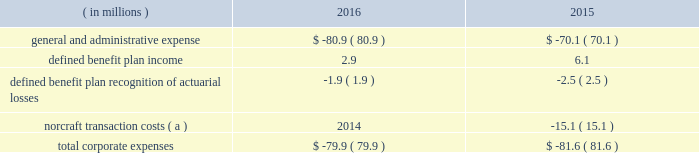Corporate corporate expenses in 2016 benefited from the absence of transaction costs associated with the norcraft acquisition ( $ 15.1 million in 2015 ) .
This benefit was offset by higher employee-related costs and lower defined benefit plan income .
( in millions ) 2016 2015 .
( a ) represents external costs directly related to the acquisition of norcraft and primarily includes expenditures for banking , legal , accounting and other similar services .
In future periods the company may record , in the corporate segment , material expense or income associated with actuarial gains and losses arising from periodic remeasurement of our liabilities for defined benefit plans .
At a minimum the company will remeasure its defined benefit plan liabilities in the fourth quarter of each year .
Remeasurements due to plan amendments and settlements may also occur in interim periods during the year .
Remeasurement of these liabilities attributable to updating our liability discount rates and expected return on assets may , in particular , result in material income or expense recognition .
Liquidity and capital resources our primary liquidity needs are to support working capital requirements , fund capital expenditures and service indebtedness , as well as to finance acquisitions , repurchase shares of our common stock and pay dividends to stockholders , as deemed appropriate .
Our principal sources of liquidity are cash on hand , cash flows from operating activities , availability under our credit facility and debt issuances in the capital markets .
Our operating income is generated by our subsidiaries .
There are no restrictions on the ability of our subsidiaries to pay dividends or make other distributions to fortune brands .
In december 2017 , our board of directors increased the quarterly cash dividend by 11% ( 11 % ) to $ 0.20 per share of our common stock .
Our board of directors will continue to evaluate dividend payment opportunities on a quarterly basis .
There can be no assurance as to when and if future dividends will be paid , and at what level , because the payment of dividends is dependent on our financial condition , results of operations , cash flows , capital requirements and other factors deemed relevant by our board of directors .
We periodically review our portfolio of brands and evaluate potential strategic transactions to increase shareholder value .
However , we cannot predict whether or when we may enter into acquisitions , joint ventures or dispositions , make any purchases of shares of our common stock under our share repurchase program , or pay dividends , or what impact any such transactions could have on our results of operations , cash flows or financial condition , whether as a result of the issuance of debt or equity securities , or otherwise .
Our cash flows from operations , borrowing availability and overall liquidity are subject to certain risks and uncertainties , including those described in the section 201citem 1a .
Risk factors . 201d in june 2016 , the company amended and restated its credit agreement to combine and rollover the existing revolving credit facility and term loan into a new standalone $ 1.25 billion revolving credit facility .
This amendment and restatement of the credit agreement was a non-cash transaction for the company .
Terms and conditions of the credit agreement , including the total commitment amount , essentially remained the same as under the 2011 credit agreement .
The revolving credit facility will mature in june 2021 and borrowings thereunder will be used for general corporate purposes .
On december 31 , 2017 and december 31 , 2016 , our outstanding borrowings under these facilities were $ 615.0 million and $ 540.0 million , respectively .
At december 31 , 2017 and december 31 , 2016 , the current portion of long- term debt was zero .
Interest rates under the facility are variable based on libor at the time of the .
In 2015 what was the ratio of the defined benefit plan income to defined benefit plan recognition of actuarial losses? 
Rationale: in 2015 for every dollar lost as part defined benefit plan recognition of actuarial losses the company record 2.44 of defined benefit plan income
Computations: (6.1 / -2.5)
Answer: -2.44. 